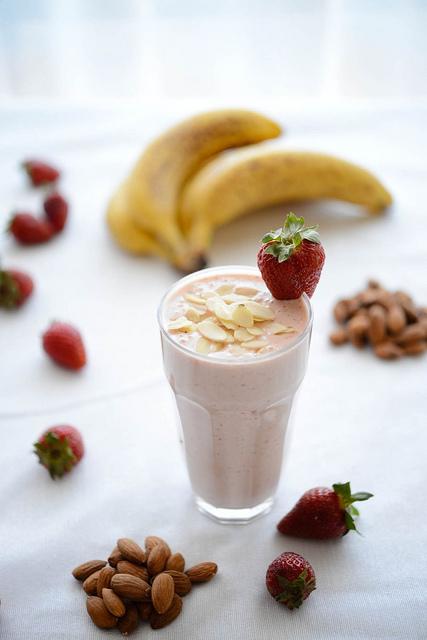How many bananas are there?
Answer briefly. 3. What kind of nuts are in the picture?
Write a very short answer. Almonds. What flavor of smoothie might this be?
Keep it brief. Strawberry banana. 